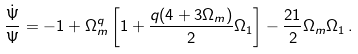Convert formula to latex. <formula><loc_0><loc_0><loc_500><loc_500>\frac { \dot { \Psi } } { \Psi } = - 1 + \Omega _ { m } ^ { q } \left [ 1 + \frac { q ( 4 + 3 \Omega _ { m } ) } { 2 } \Omega _ { 1 } \right ] - \frac { 2 1 } { 2 } \Omega _ { m } \Omega _ { 1 } \, .</formula> 